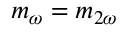<formula> <loc_0><loc_0><loc_500><loc_500>m _ { \omega } = m _ { 2 \omega }</formula> 